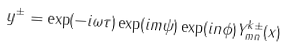Convert formula to latex. <formula><loc_0><loc_0><loc_500><loc_500>y ^ { \pm } = \exp ( - i \omega \tau ) \exp ( i m \psi ) \exp ( i n \phi ) Y ^ { k \pm } _ { m n } ( x )</formula> 